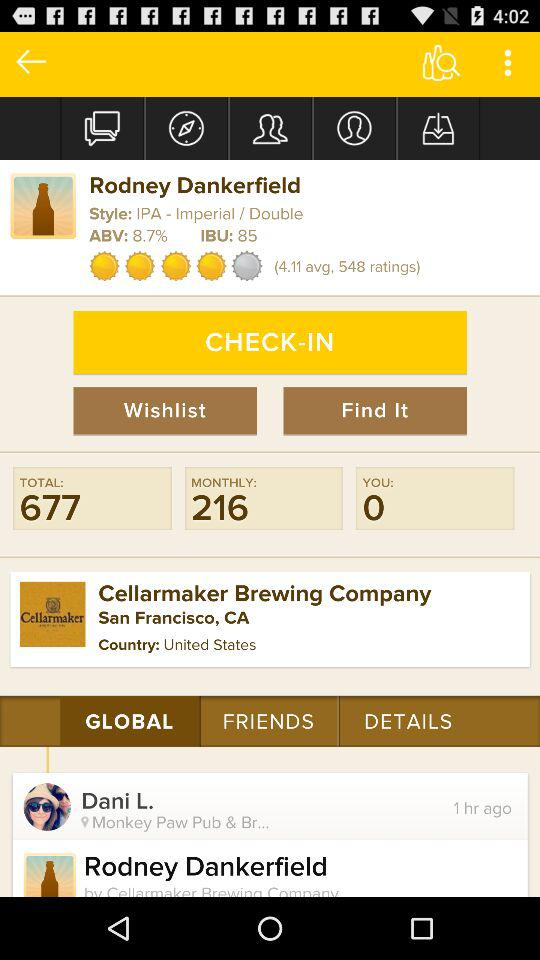What's the ABV of "Rodney Dankerfield"? The ABV of "Rodney Dankerfield" is 8.7%. 